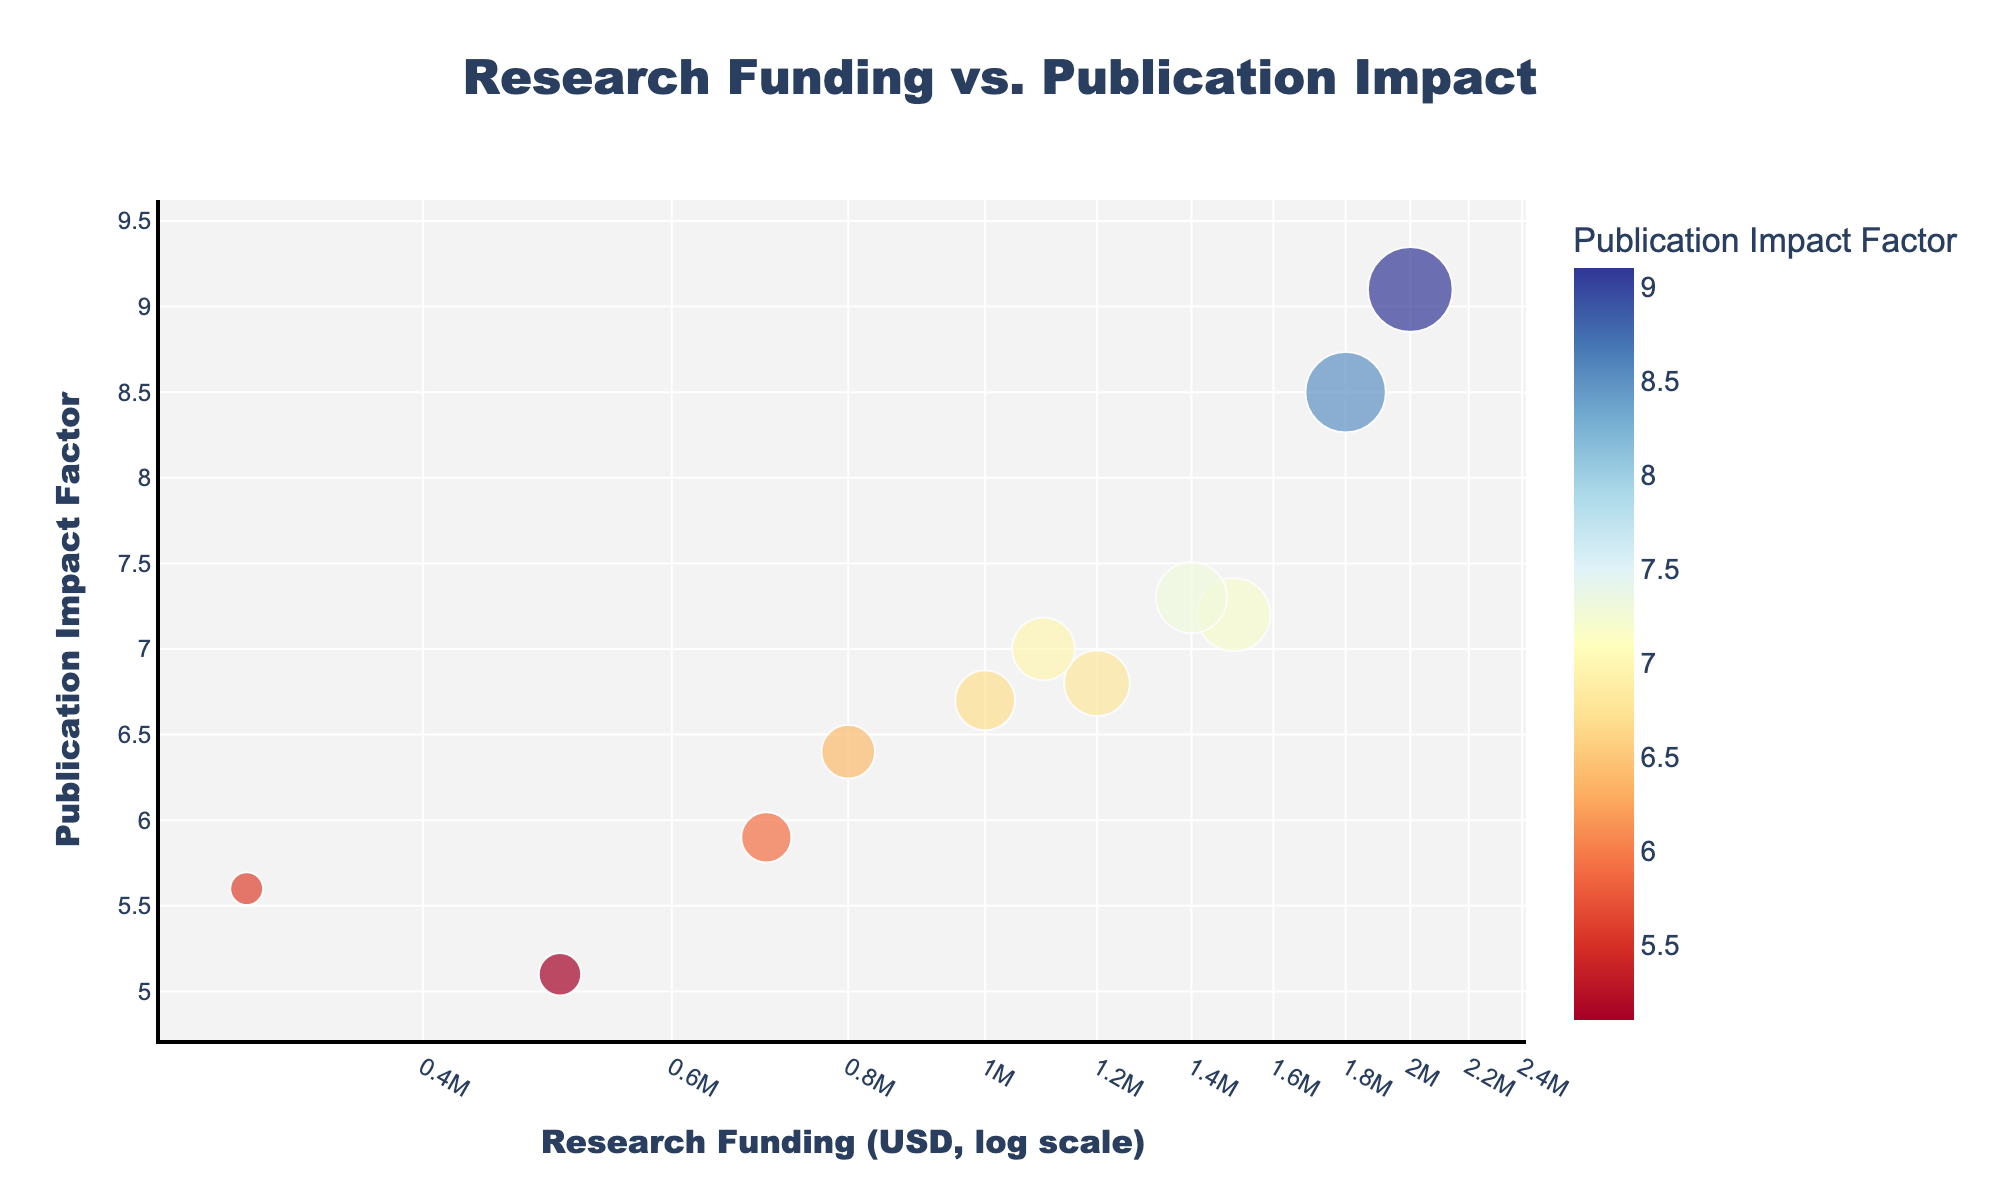What is the title of the figure? The title is usually positioned at the top center of the plot. In this figure, the title text is clear and large.
Answer: Research Funding vs. Publication Impact Which department received the highest research funding? Look for the data point located farthest to the right on the x-axis, indicating the highest funding.
Answer: Engineering Which department has the lowest publication impact factor? Identify the data point that is positioned lowest on the y-axis, representing the smallest impact factor.
Answer: Sociology What axis uses a logarithmic scale? The text next to the x-axis will often mention the type of scale. Here, the x-axis is specifically labeled with "log scale."
Answer: x-axis How many departments are represented in the figure? Count the number of distinct data points in the scatter plot. Each point corresponds to one department.
Answer: 11 Which department is closest to having an equal balance between research funding and publication impact factor? Look for the department closest to the intersection of the middle-range values on both axes. This is a subjective question and deliberately ambiguous to stimulate discussion.
Answer: Environmental Science Between Physics and Biology, which one has a higher publication impact factor? Compare the y-axis positions of the data points labeled "Physics" and "Biology"; the higher point means a higher impact factor.
Answer: Biology What is the difference in research funding between Mathematics and Sociology departments? Compare the x-axis values of Mathematics and Sociology, then calculate the difference. Mathematics is at 800,000 and Sociology at 500,000; thus, 800,000 - 500,000 = 300,000.
Answer: 300,000 USD If you only consider departments with a publication impact factor above 7, how much total research funding do they receive? Identify the departments with y-values greater than 7, sum their corresponding x-values. This includes Physics, Biology, Computer Science, Engineering, and Environmental Science. Total = 1500000 + 1800000 + 1100000 + 2000000 + 1400000 = 7800000.
Answer: 7,800,000 USD What does the color gradient in the figure represent? The color gradient will usually show a varying feature across data points. Here, the legend or color bar indicates it's based on the publication impact factor.
Answer: Publication Impact Factor 